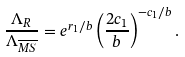<formula> <loc_0><loc_0><loc_500><loc_500>\frac { \Lambda _ { R } } { \Lambda _ { \overline { M S } } } = e ^ { r _ { 1 } / b } \left ( \frac { 2 c _ { 1 } } { b } \right ) ^ { - c _ { 1 } / b } .</formula> 